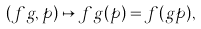<formula> <loc_0><loc_0><loc_500><loc_500>( f g , p ) \mapsto f g ( p ) = f ( g p ) ,</formula> 